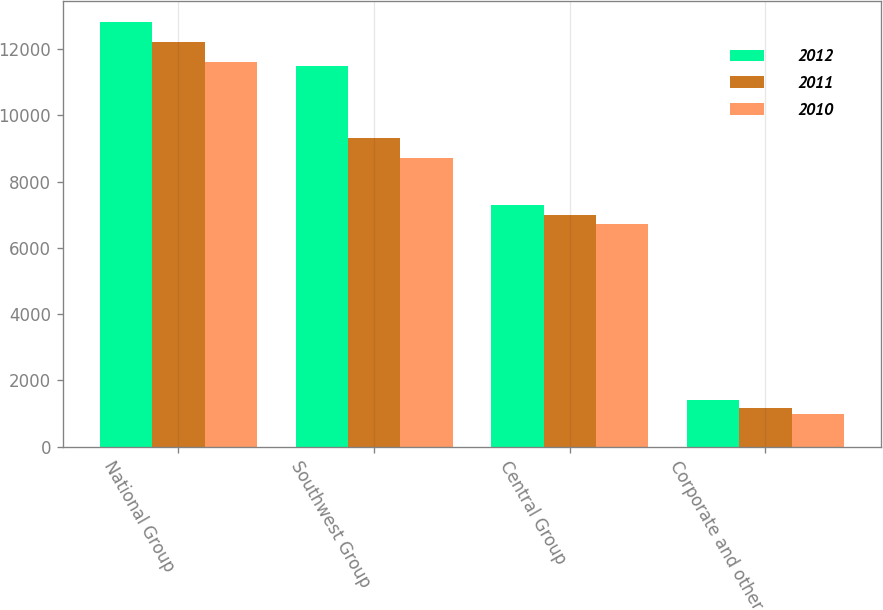Convert chart. <chart><loc_0><loc_0><loc_500><loc_500><stacked_bar_chart><ecel><fcel>National Group<fcel>Southwest Group<fcel>Central Group<fcel>Corporate and other<nl><fcel>2012<fcel>12809<fcel>11506<fcel>7305<fcel>1393<nl><fcel>2011<fcel>12224<fcel>9311<fcel>6982<fcel>1165<nl><fcel>2010<fcel>11624<fcel>8700<fcel>6727<fcel>984<nl></chart> 